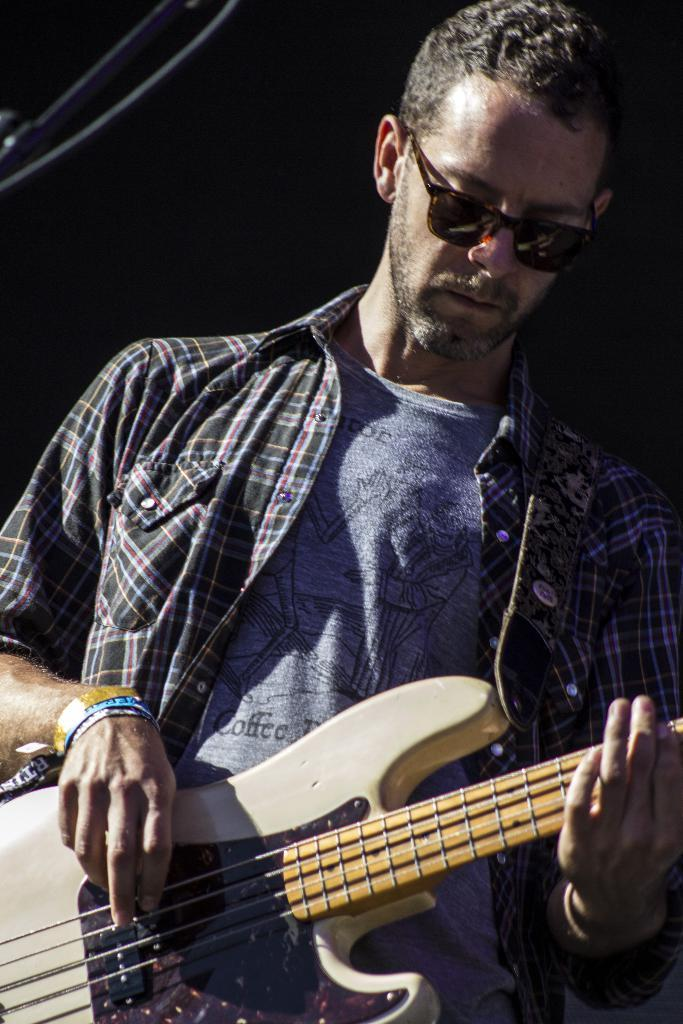Who is the main subject in the image? There is a man in the image. What is the man doing in the image? The man is standing and playing a guitar. Where is the river located in the image? There is no river present in the image. What type of fold can be seen in the man's clothing in the image? The man's clothing does not have any visible folds in the image. 